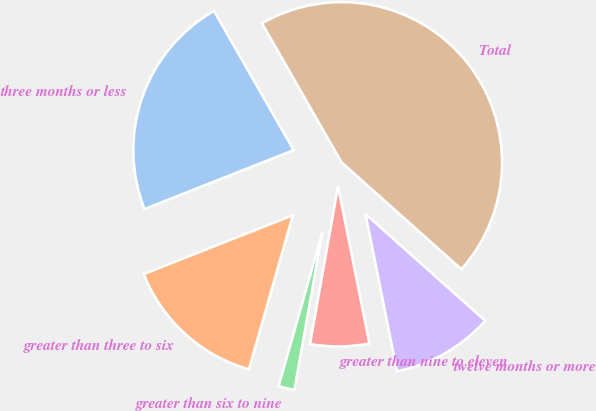Convert chart to OTSL. <chart><loc_0><loc_0><loc_500><loc_500><pie_chart><fcel>three months or less<fcel>greater than three to six<fcel>greater than six to nine<fcel>greater than nine to eleven<fcel>twelve months or more<fcel>Total<nl><fcel>22.71%<fcel>14.59%<fcel>1.62%<fcel>5.94%<fcel>10.27%<fcel>44.87%<nl></chart> 